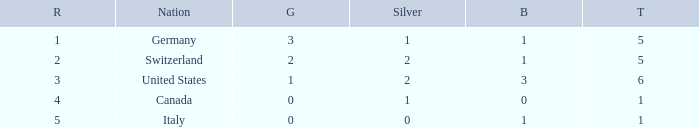How many golds for nations with over 0 silvers, over 1 total, and over 3 bronze? 0.0. 